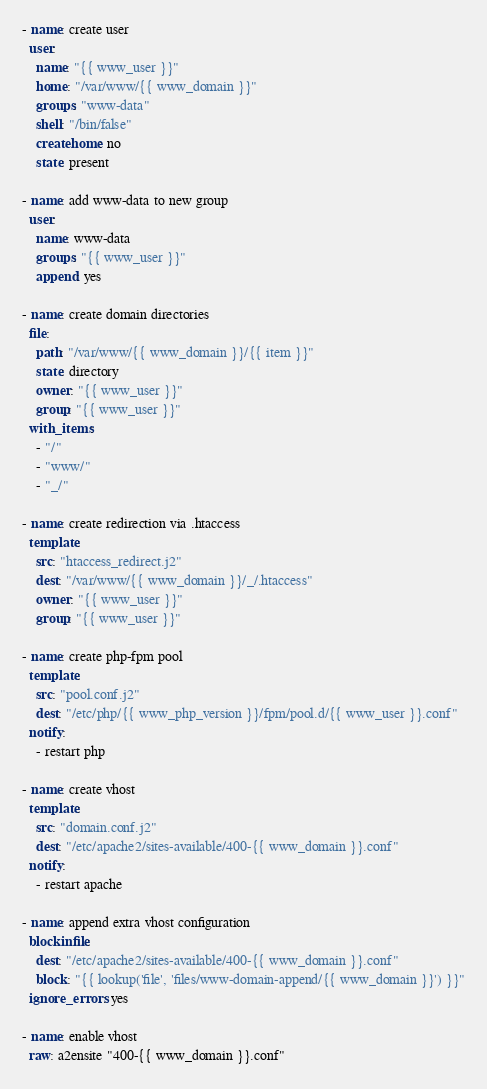<code> <loc_0><loc_0><loc_500><loc_500><_YAML_>- name: create user
  user: 
    name: "{{ www_user }}"
    home: "/var/www/{{ www_domain }}"
    groups: "www-data"
    shell: "/bin/false"
    createhome: no 
    state: present

- name: add www-data to new group
  user:
    name: www-data
    groups: "{{ www_user }}"
    append: yes

- name: create domain directories
  file: 
    path: "/var/www/{{ www_domain }}/{{ item }}" 
    state: directory 
    owner: "{{ www_user }}"
    group: "{{ www_user }}"
  with_items:
    - "/"
    - "www/"
    - "_/"
  
- name: create redirection via .htaccess
  template: 
    src: "htaccess_redirect.j2" 
    dest: "/var/www/{{ www_domain }}/_/.htaccess"
    owner: "{{ www_user }}"
    group: "{{ www_user }}"

- name: create php-fpm pool
  template:
    src: "pool.conf.j2"
    dest: "/etc/php/{{ www_php_version }}/fpm/pool.d/{{ www_user }}.conf"
  notify:
    - restart php

- name: create vhost 
  template:
    src: "domain.conf.j2"
    dest: "/etc/apache2/sites-available/400-{{ www_domain }}.conf"
  notify:
    - restart apache

- name: append extra vhost configuration
  blockinfile:
    dest: "/etc/apache2/sites-available/400-{{ www_domain }}.conf"
    block: "{{ lookup('file', 'files/www-domain-append/{{ www_domain }}') }}"
  ignore_errors: yes

- name: enable vhost
  raw: a2ensite "400-{{ www_domain }}.conf"

</code> 